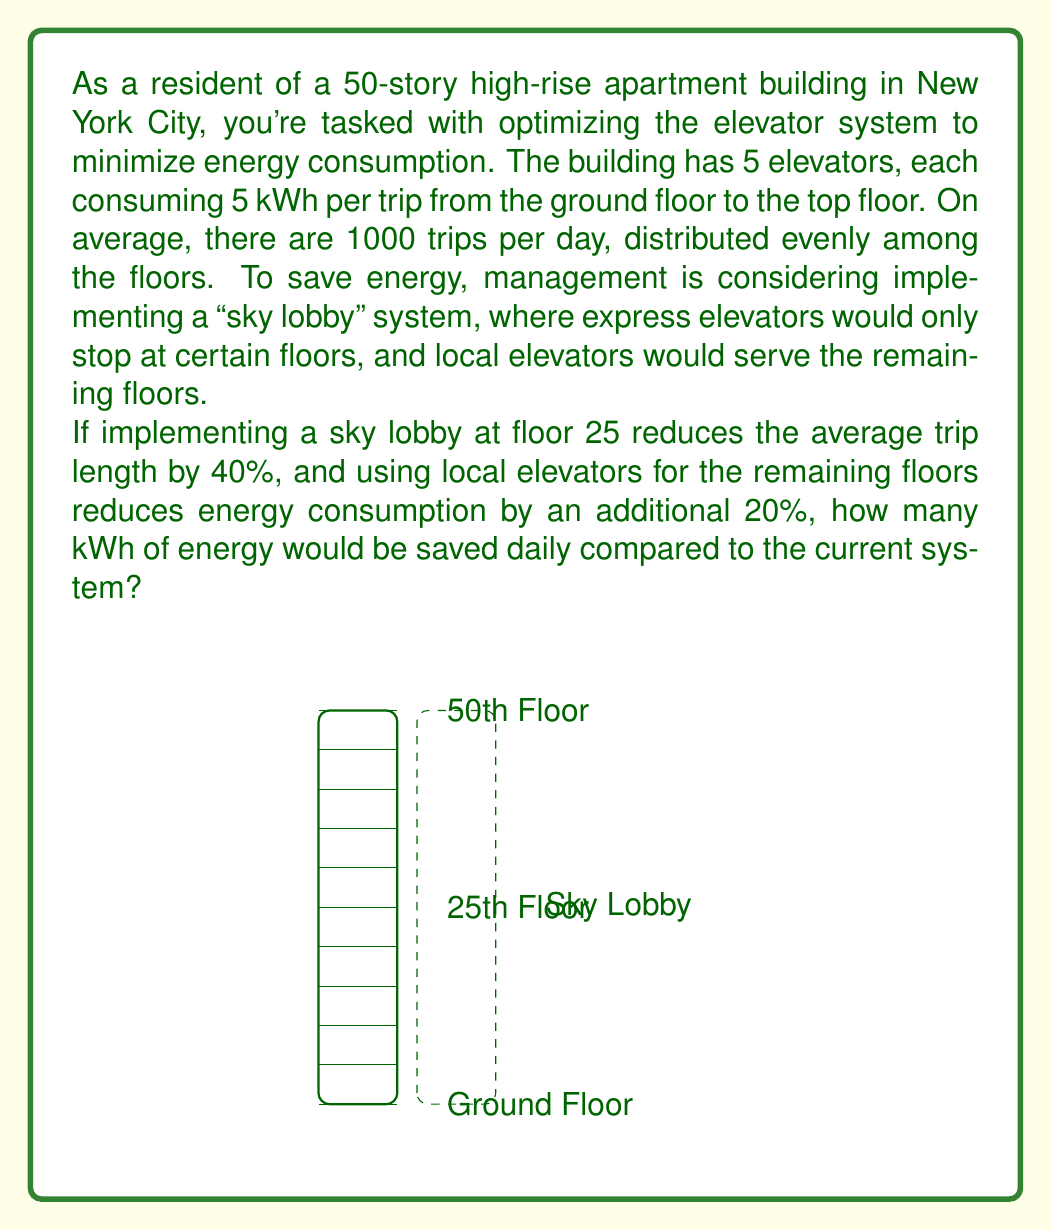Can you solve this math problem? Let's approach this problem step-by-step:

1) First, calculate the current daily energy consumption:
   - Energy per trip to top floor = 5 kWh
   - Number of trips per day = 1000
   - Average trip length = 25 floors (as trips are evenly distributed)
   - Current daily consumption = $5 \cdot 1000 \cdot \frac{25}{50} = 2500$ kWh

2) Calculate the reduction from implementing the sky lobby:
   - New average trip length = 25 floors * (1 - 0.40) = 15 floors
   - New consumption after sky lobby = $5 \cdot 1000 \cdot \frac{15}{50} = 1500$ kWh

3) Apply the additional 20% reduction from local elevators:
   - Final daily consumption = 1500 kWh * (1 - 0.20) = 1200 kWh

4) Calculate the total energy saved:
   - Energy saved = Current consumption - Final consumption
   - Energy saved = 2500 kWh - 1200 kWh = 1300 kWh

Therefore, the new system would save 1300 kWh of energy daily.
Answer: 1300 kWh 